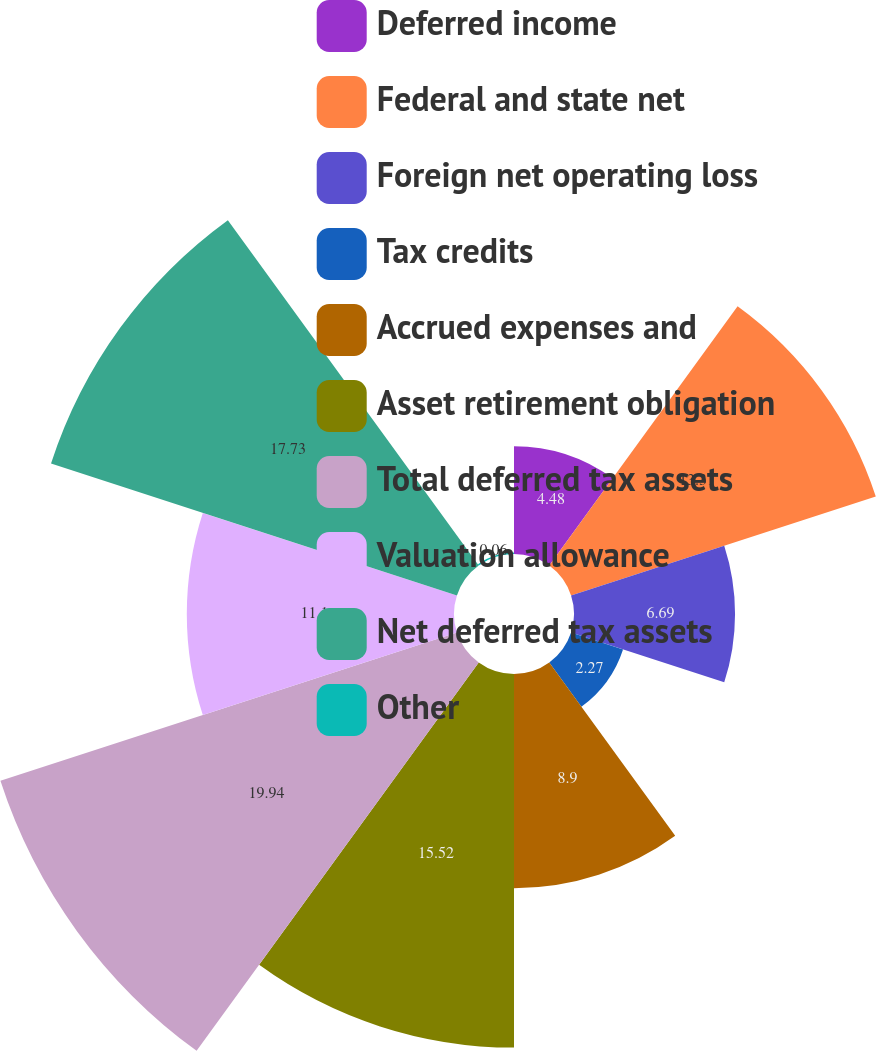<chart> <loc_0><loc_0><loc_500><loc_500><pie_chart><fcel>Deferred income<fcel>Federal and state net<fcel>Foreign net operating loss<fcel>Tax credits<fcel>Accrued expenses and<fcel>Asset retirement obligation<fcel>Total deferred tax assets<fcel>Valuation allowance<fcel>Net deferred tax assets<fcel>Other<nl><fcel>4.48%<fcel>13.31%<fcel>6.69%<fcel>2.27%<fcel>8.9%<fcel>15.52%<fcel>19.94%<fcel>11.1%<fcel>17.73%<fcel>0.06%<nl></chart> 